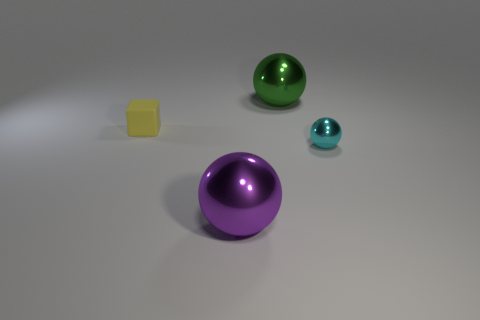Add 2 metal balls. How many objects exist? 6 Subtract all green metal balls. How many balls are left? 2 Subtract all purple balls. How many balls are left? 2 Subtract all brown cubes. Subtract all purple cylinders. How many cubes are left? 1 Subtract all gray cylinders. How many green balls are left? 1 Subtract all small blue rubber objects. Subtract all green balls. How many objects are left? 3 Add 4 purple spheres. How many purple spheres are left? 5 Add 1 large green spheres. How many large green spheres exist? 2 Subtract 0 cyan cubes. How many objects are left? 4 Subtract all spheres. How many objects are left? 1 